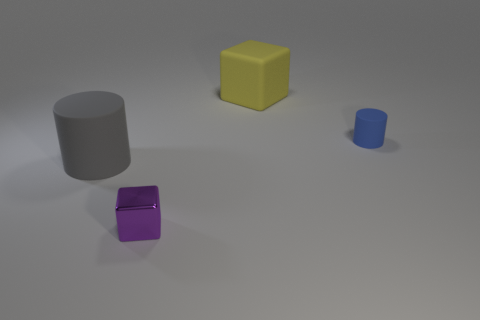Add 2 large red metallic spheres. How many objects exist? 6 Subtract 1 yellow blocks. How many objects are left? 3 Subtract all big brown matte blocks. Subtract all big rubber blocks. How many objects are left? 3 Add 2 large objects. How many large objects are left? 4 Add 2 purple shiny cubes. How many purple shiny cubes exist? 3 